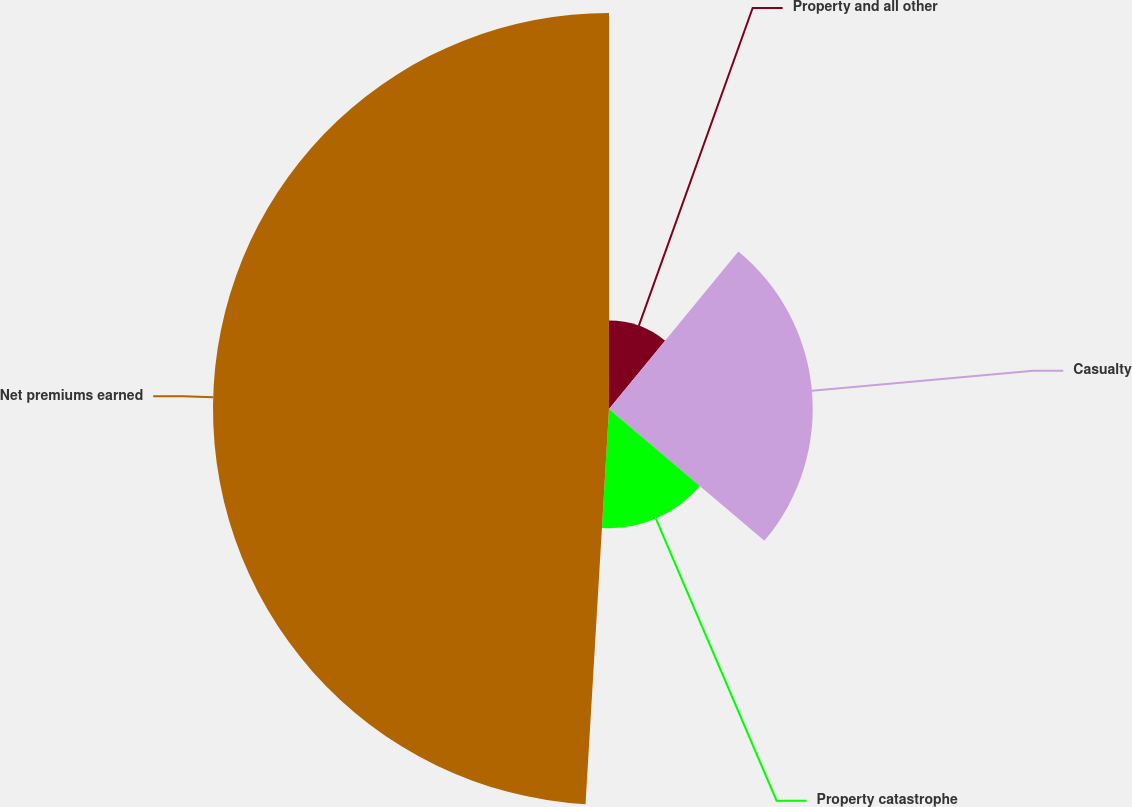<chart> <loc_0><loc_0><loc_500><loc_500><pie_chart><fcel>Property and all other<fcel>Casualty<fcel>Property catastrophe<fcel>Net premiums earned<nl><fcel>10.95%<fcel>25.24%<fcel>14.76%<fcel>49.06%<nl></chart> 